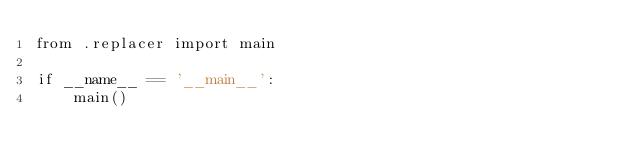Convert code to text. <code><loc_0><loc_0><loc_500><loc_500><_Python_>from .replacer import main

if __name__ == '__main__':
    main()
</code> 